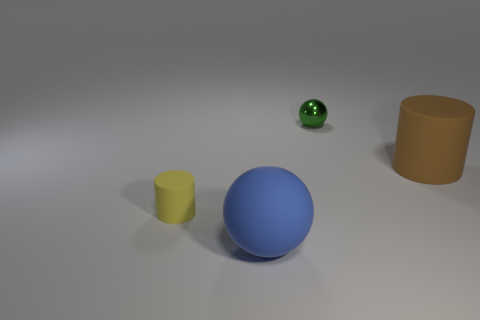The cylinder left of the thing that is behind the matte cylinder right of the tiny rubber cylinder is what color?
Offer a very short reply. Yellow. What is the color of the small cylinder that is made of the same material as the large blue sphere?
Make the answer very short. Yellow. There is a rubber cylinder left of the green object; is its size the same as the blue object?
Give a very brief answer. No. The shiny ball that is the same size as the yellow cylinder is what color?
Your answer should be very brief. Green. Are any small rubber blocks visible?
Offer a very short reply. No. There is a ball that is behind the big object on the left side of the sphere behind the tiny yellow cylinder; what is its size?
Keep it short and to the point. Small. How many other things are the same size as the brown cylinder?
Make the answer very short. 1. There is a cylinder in front of the brown thing; what size is it?
Your answer should be very brief. Small. Is there anything else of the same color as the tiny sphere?
Give a very brief answer. No. Is the small object that is on the left side of the tiny green metallic ball made of the same material as the large blue object?
Give a very brief answer. Yes. 